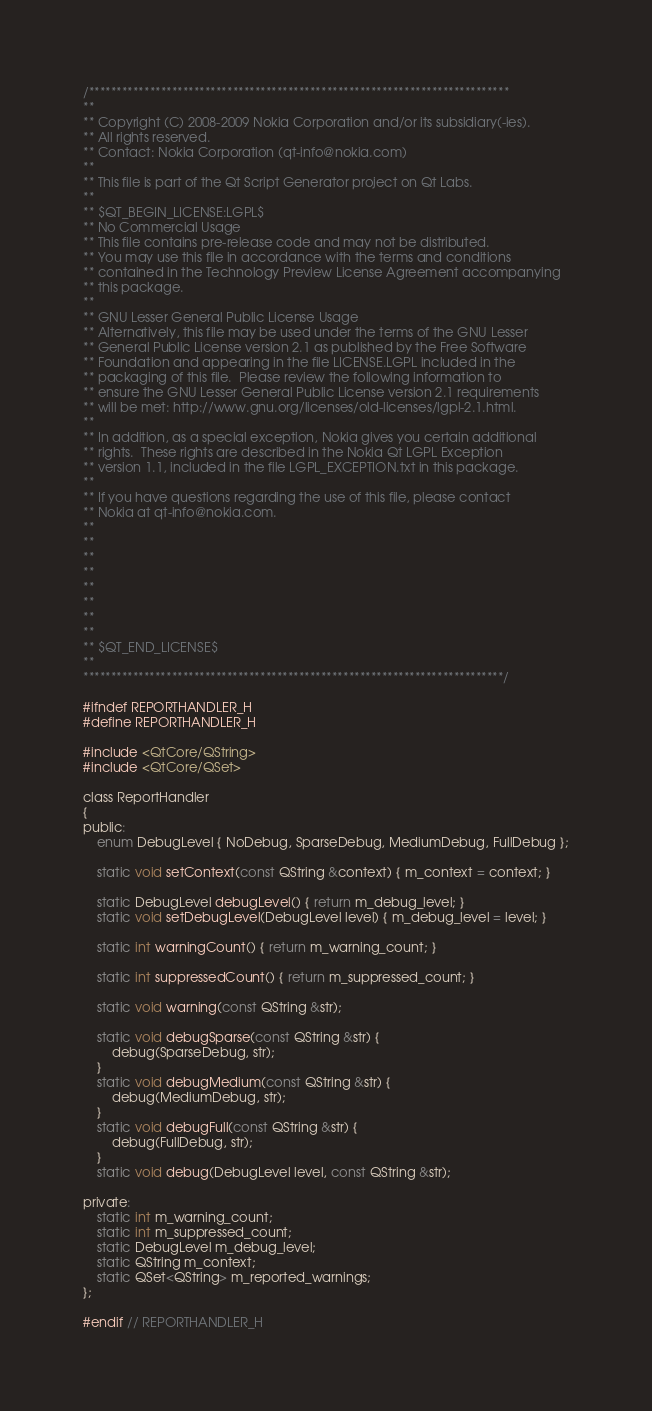<code> <loc_0><loc_0><loc_500><loc_500><_C_>/****************************************************************************
**
** Copyright (C) 2008-2009 Nokia Corporation and/or its subsidiary(-ies).
** All rights reserved.
** Contact: Nokia Corporation (qt-info@nokia.com)
**
** This file is part of the Qt Script Generator project on Qt Labs.
**
** $QT_BEGIN_LICENSE:LGPL$
** No Commercial Usage
** This file contains pre-release code and may not be distributed.
** You may use this file in accordance with the terms and conditions
** contained in the Technology Preview License Agreement accompanying
** this package.
**
** GNU Lesser General Public License Usage
** Alternatively, this file may be used under the terms of the GNU Lesser
** General Public License version 2.1 as published by the Free Software
** Foundation and appearing in the file LICENSE.LGPL included in the
** packaging of this file.  Please review the following information to
** ensure the GNU Lesser General Public License version 2.1 requirements
** will be met: http://www.gnu.org/licenses/old-licenses/lgpl-2.1.html.
**
** In addition, as a special exception, Nokia gives you certain additional
** rights.  These rights are described in the Nokia Qt LGPL Exception
** version 1.1, included in the file LGPL_EXCEPTION.txt in this package.
**
** If you have questions regarding the use of this file, please contact
** Nokia at qt-info@nokia.com.
**
**
**
**
**
**
**
**
** $QT_END_LICENSE$
**
****************************************************************************/

#ifndef REPORTHANDLER_H
#define REPORTHANDLER_H

#include <QtCore/QString>
#include <QtCore/QSet>

class ReportHandler
{
public:
    enum DebugLevel { NoDebug, SparseDebug, MediumDebug, FullDebug };

    static void setContext(const QString &context) { m_context = context; }

    static DebugLevel debugLevel() { return m_debug_level; }
    static void setDebugLevel(DebugLevel level) { m_debug_level = level; }

    static int warningCount() { return m_warning_count; }

    static int suppressedCount() { return m_suppressed_count; }

    static void warning(const QString &str);

    static void debugSparse(const QString &str) {
        debug(SparseDebug, str);
    }
    static void debugMedium(const QString &str) {
        debug(MediumDebug, str);
    }
    static void debugFull(const QString &str) {
        debug(FullDebug, str);
    }
    static void debug(DebugLevel level, const QString &str);

private:
    static int m_warning_count;
    static int m_suppressed_count;
    static DebugLevel m_debug_level;
    static QString m_context;
    static QSet<QString> m_reported_warnings;
};

#endif // REPORTHANDLER_H
</code> 